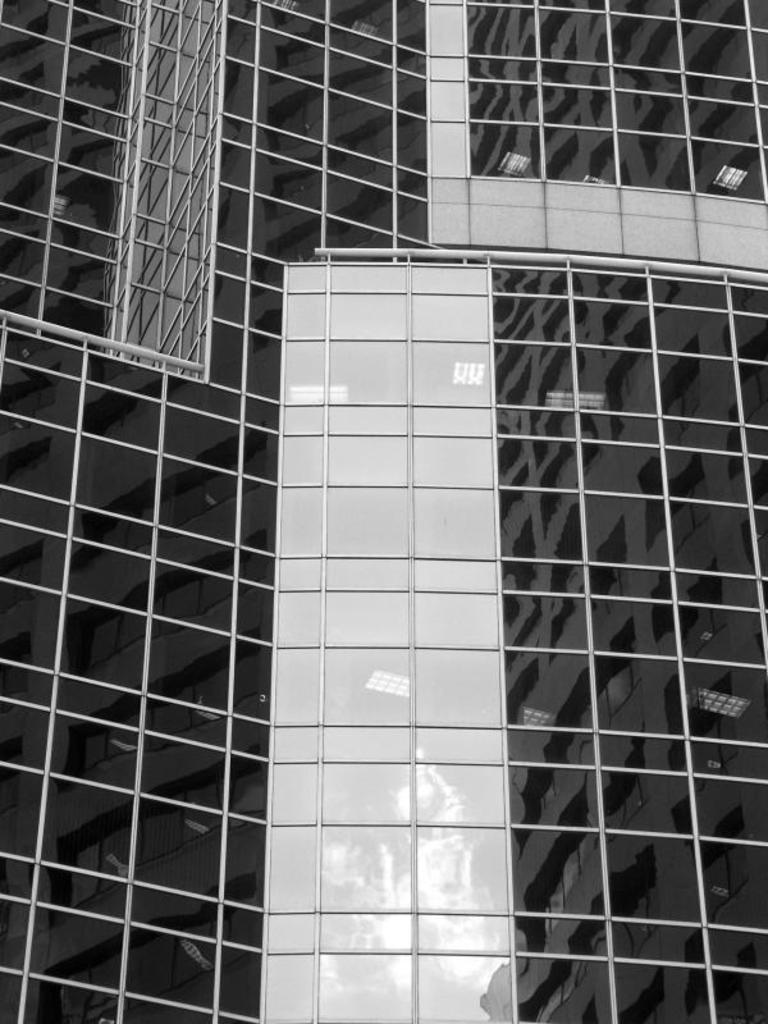What type of material is featured in the image? There is an iron net in the image. What color scheme is used in the image? The image is in black and white. What type of produce can be seen growing in the image? There is no produce present in the image; it features an iron net. What type of song is playing in the background of the image? There is no song playing in the background of the image; it is a still image of an iron net. 